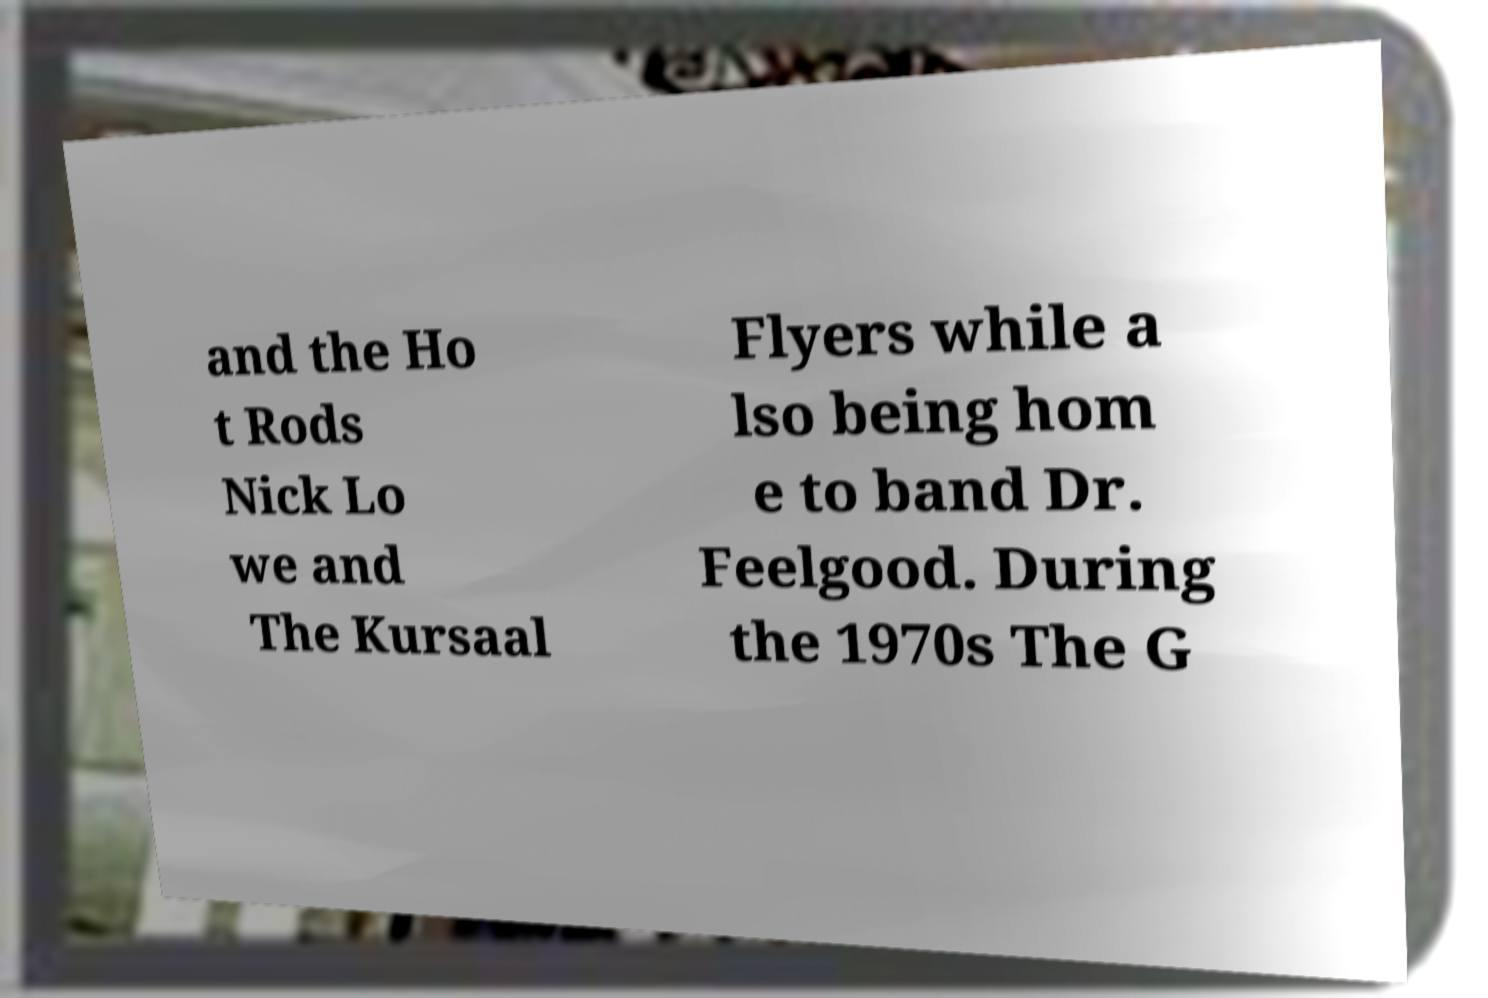I need the written content from this picture converted into text. Can you do that? and the Ho t Rods Nick Lo we and The Kursaal Flyers while a lso being hom e to band Dr. Feelgood. During the 1970s The G 